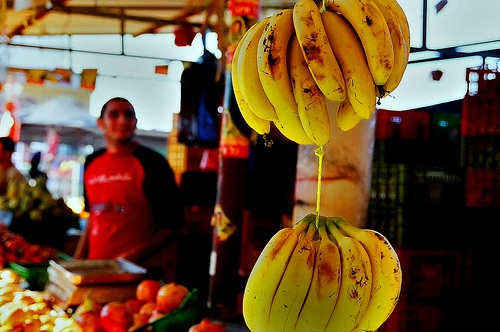Describe the objects in this image and their specific colors. I can see banana in red, olive, and orange tones, banana in red, orange, olive, and maroon tones, people in red, black, and maroon tones, banana in red, gold, olive, and maroon tones, and apple in red and maroon tones in this image. 